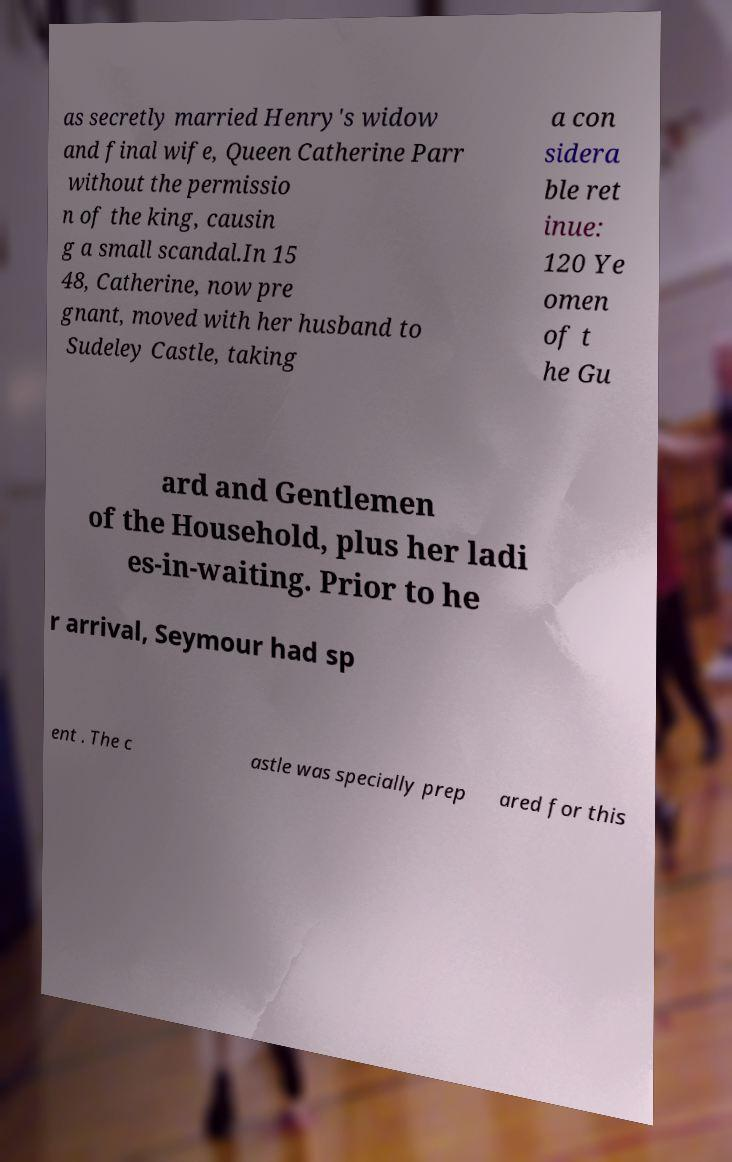Can you read and provide the text displayed in the image?This photo seems to have some interesting text. Can you extract and type it out for me? as secretly married Henry's widow and final wife, Queen Catherine Parr without the permissio n of the king, causin g a small scandal.In 15 48, Catherine, now pre gnant, moved with her husband to Sudeley Castle, taking a con sidera ble ret inue: 120 Ye omen of t he Gu ard and Gentlemen of the Household, plus her ladi es-in-waiting. Prior to he r arrival, Seymour had sp ent . The c astle was specially prep ared for this 